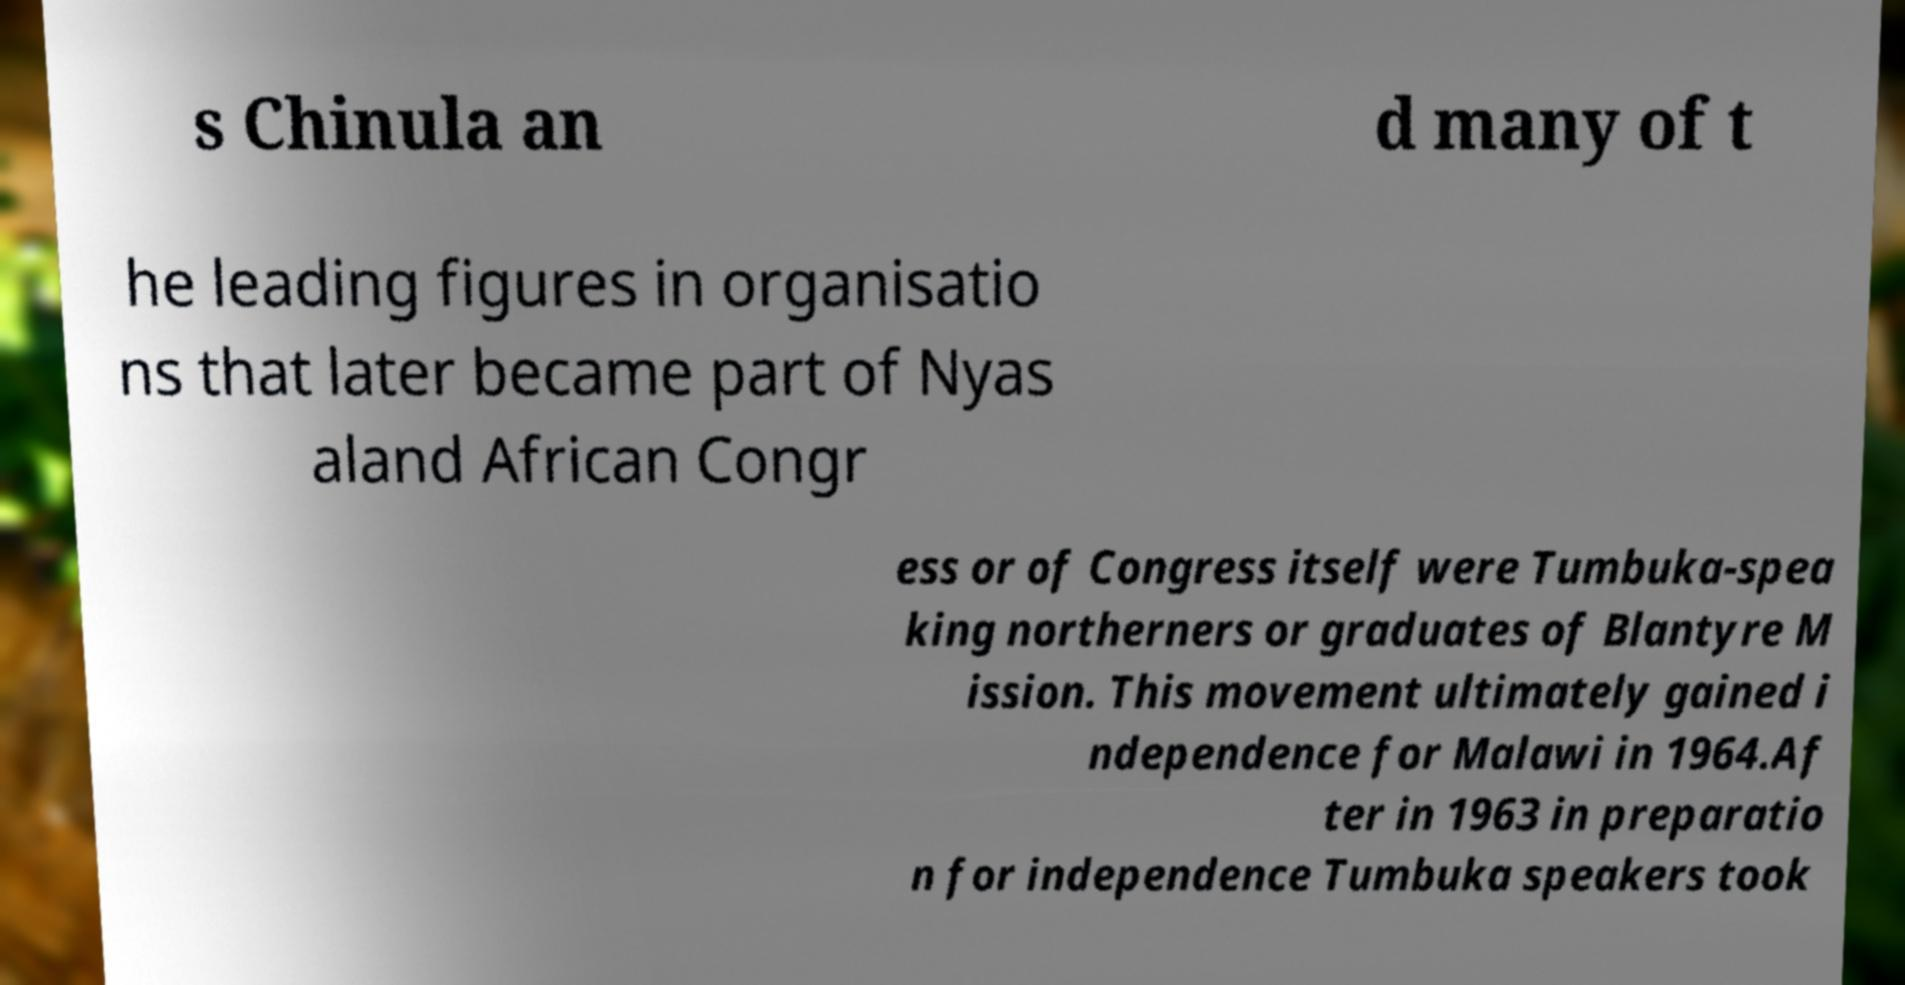Can you read and provide the text displayed in the image?This photo seems to have some interesting text. Can you extract and type it out for me? s Chinula an d many of t he leading figures in organisatio ns that later became part of Nyas aland African Congr ess or of Congress itself were Tumbuka-spea king northerners or graduates of Blantyre M ission. This movement ultimately gained i ndependence for Malawi in 1964.Af ter in 1963 in preparatio n for independence Tumbuka speakers took 